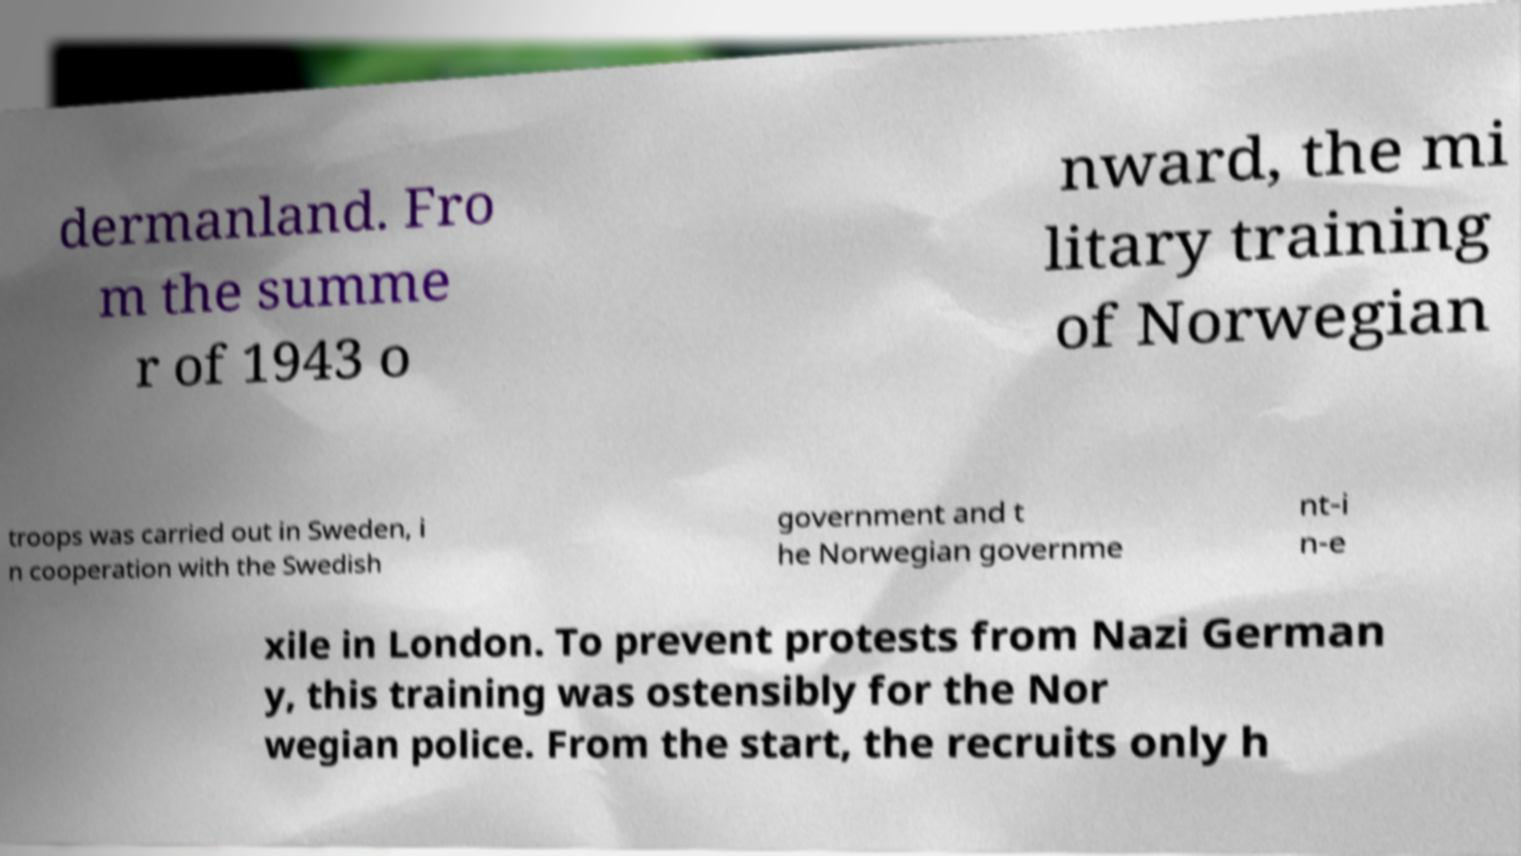Could you extract and type out the text from this image? dermanland. Fro m the summe r of 1943 o nward, the mi litary training of Norwegian troops was carried out in Sweden, i n cooperation with the Swedish government and t he Norwegian governme nt-i n-e xile in London. To prevent protests from Nazi German y, this training was ostensibly for the Nor wegian police. From the start, the recruits only h 